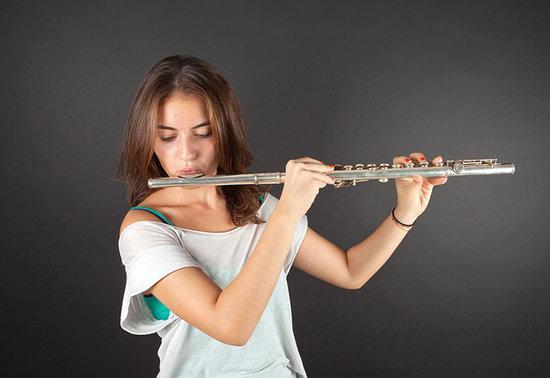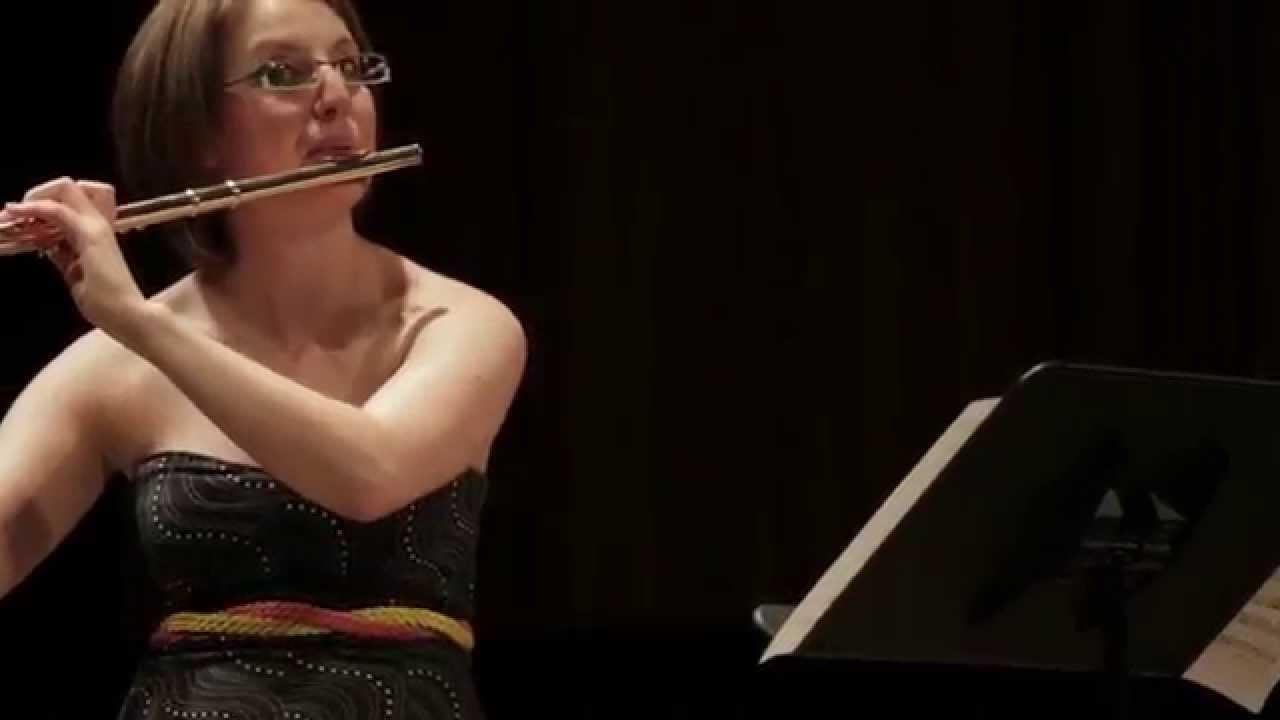The first image is the image on the left, the second image is the image on the right. Examine the images to the left and right. Is the description "A woman smiles while she holds a flute in one of the images." accurate? Answer yes or no. No. The first image is the image on the left, the second image is the image on the right. For the images shown, is this caption "In at least one image there is a woman with long hair  holding but no playing the flute." true? Answer yes or no. No. 